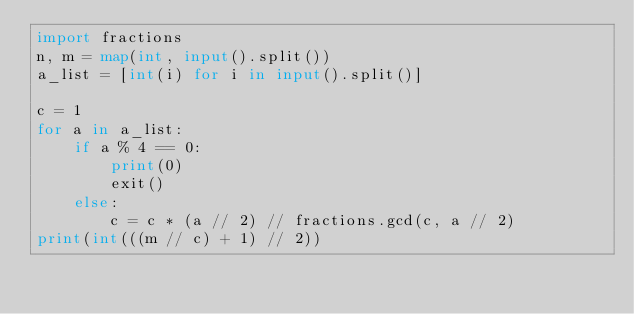<code> <loc_0><loc_0><loc_500><loc_500><_Python_>import fractions
n, m = map(int, input().split())
a_list = [int(i) for i in input().split()]

c = 1
for a in a_list:
    if a % 4 == 0:
        print(0)
        exit()
    else:
        c = c * (a // 2) // fractions.gcd(c, a // 2)
print(int(((m // c) + 1) // 2))</code> 